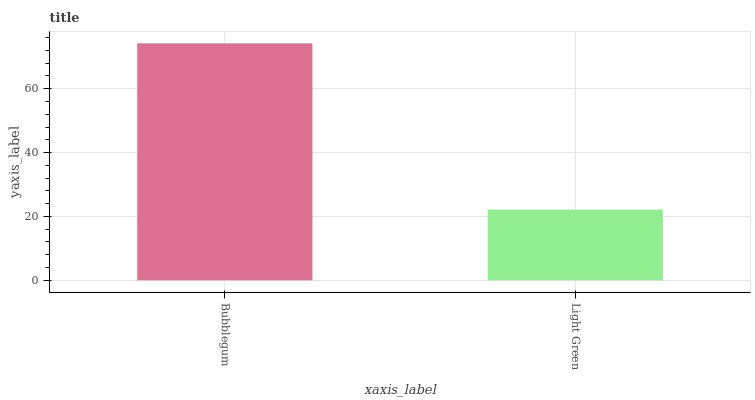Is Light Green the maximum?
Answer yes or no. No. Is Bubblegum greater than Light Green?
Answer yes or no. Yes. Is Light Green less than Bubblegum?
Answer yes or no. Yes. Is Light Green greater than Bubblegum?
Answer yes or no. No. Is Bubblegum less than Light Green?
Answer yes or no. No. Is Bubblegum the high median?
Answer yes or no. Yes. Is Light Green the low median?
Answer yes or no. Yes. Is Light Green the high median?
Answer yes or no. No. Is Bubblegum the low median?
Answer yes or no. No. 